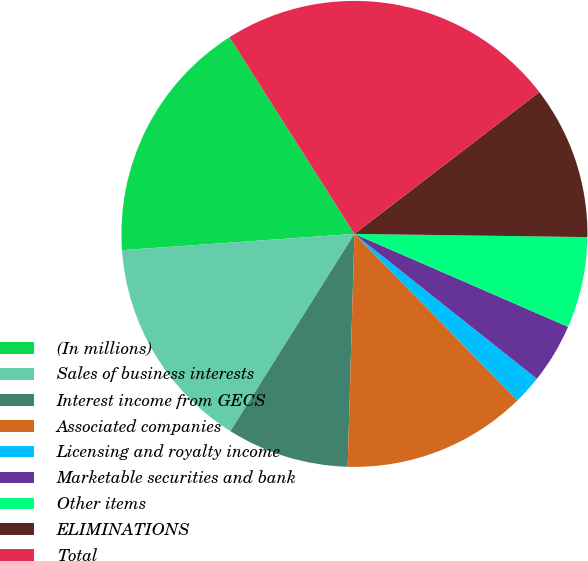<chart> <loc_0><loc_0><loc_500><loc_500><pie_chart><fcel>(In millions)<fcel>Sales of business interests<fcel>Interest income from GECS<fcel>Associated companies<fcel>Licensing and royalty income<fcel>Marketable securities and bank<fcel>Other items<fcel>ELIMINATIONS<fcel>Total<nl><fcel>17.11%<fcel>14.95%<fcel>8.47%<fcel>12.79%<fcel>1.99%<fcel>4.15%<fcel>6.31%<fcel>10.63%<fcel>23.59%<nl></chart> 